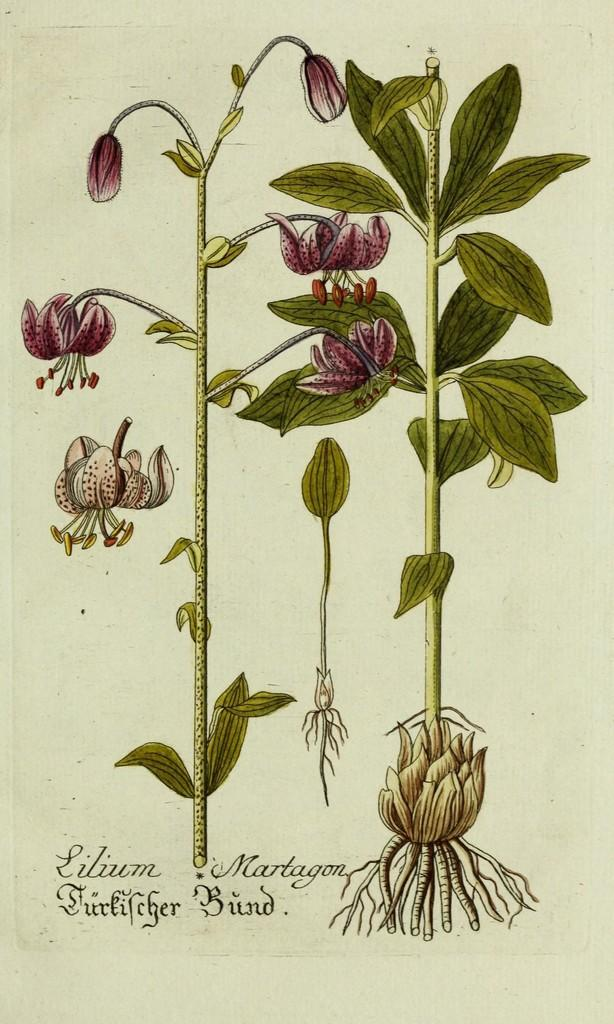What is depicted in the image? There is an art of two flower plants in the image. Where are the flower plants located? The flower plants are on a paper. What else can be seen on the paper besides the flower plants? There is text below the flower plants on the paper. How does the bear interact with the flower plants in the image? There is no bear present in the image; it only features two flower plants and text on a paper. 